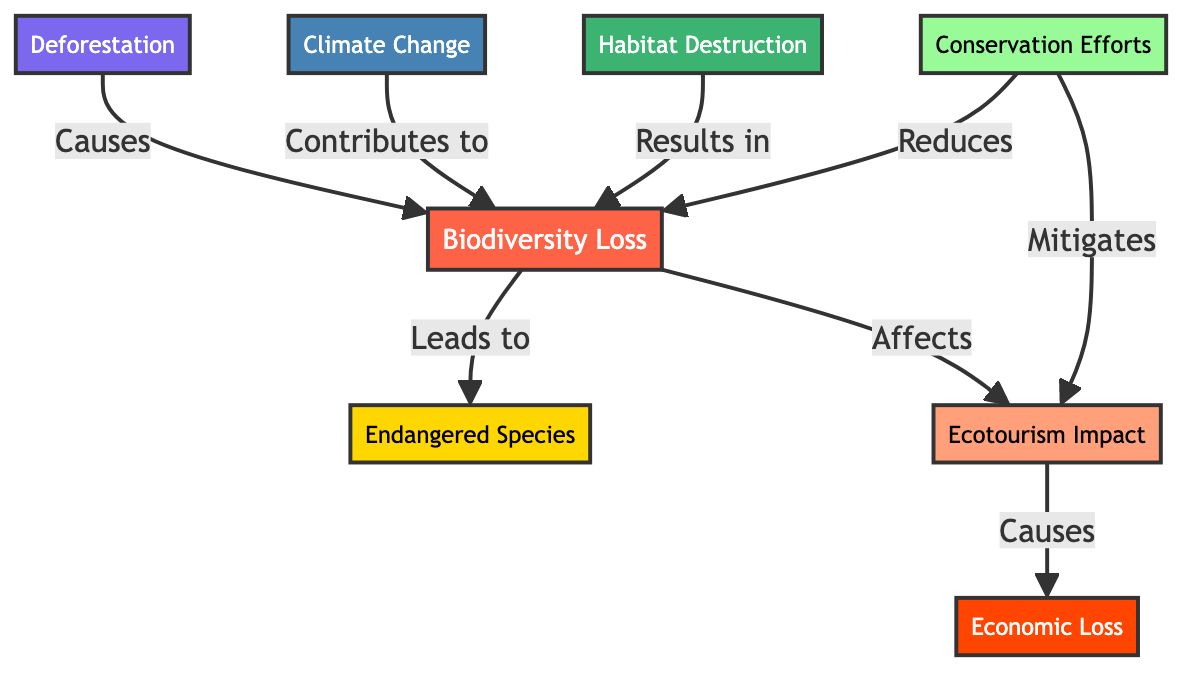What is the primary node in the diagram? The primary node is the main focus of the diagram, which is "Biodiversity Loss." It is the first node in the flowchart and is colored in red to indicate its significance.
Answer: Biodiversity Loss How many total nodes are present in the diagram? The diagram consists of eight nodes, including "Biodiversity Loss" and its interconnected causes and effects. Each distinct concept represented is counted as a separate node.
Answer: 8 Which factor directly leads to "Endangered Species"? The factor that directly leads to "Endangered Species" is "Biodiversity Loss." The diagram conveys this relationship clearly, indicating a direct consequence of biodiversity decline.
Answer: Biodiversity Loss What effect does "Ecotourism Impact" have on the economy? The diagram illustrates that "Ecotourism Impact" causes "Economic Loss," indicating that the decline in ecotourism negatively affects economic conditions.
Answer: Economic Loss How does "Conservation Efforts" influence "Biodiversity Loss"? The diagram shows that "Conservation Efforts" reduces "Biodiversity Loss," suggesting that these efforts play a crucial role in mitigating losses in biodiversity.
Answer: Reduces Which node is affected by both "Habitat Destruction" and "Climate Change"? "Biodiversity Loss" is the node affected by both "Habitat Destruction" and "Climate Change," indicating that both factors contribute to this larger problem.
Answer: Biodiversity Loss What is the relationship between "Conservation Efforts" and "Ecotourism Impact"? "Conservation Efforts" mitigates "Ecotourism Impact," showing that effective conservation can lessen negative effects on ecotourism destinations.
Answer: Mitigates Which category color represents "Endangered Species"? The node representing "Endangered Species" is colored in yellow. Each node has a specific color indicating its category, and yellow is assigned to this particular concept.
Answer: Yellow 